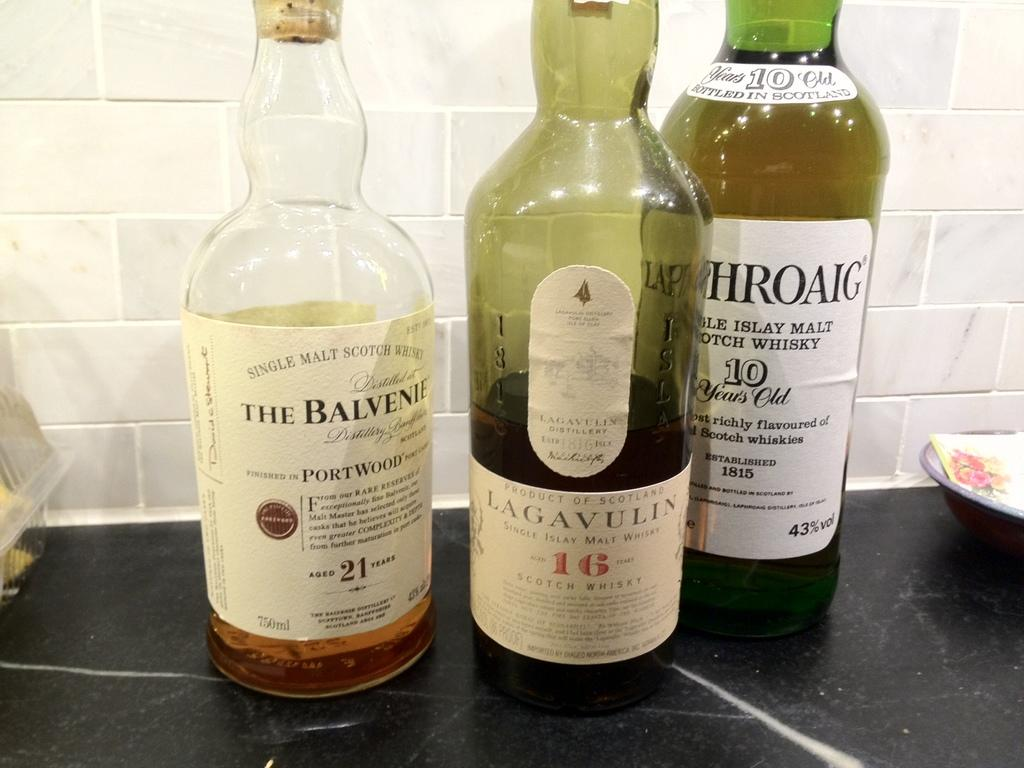<image>
Create a compact narrative representing the image presented. The bottle of Lagavulin is not a popular whiskey. 